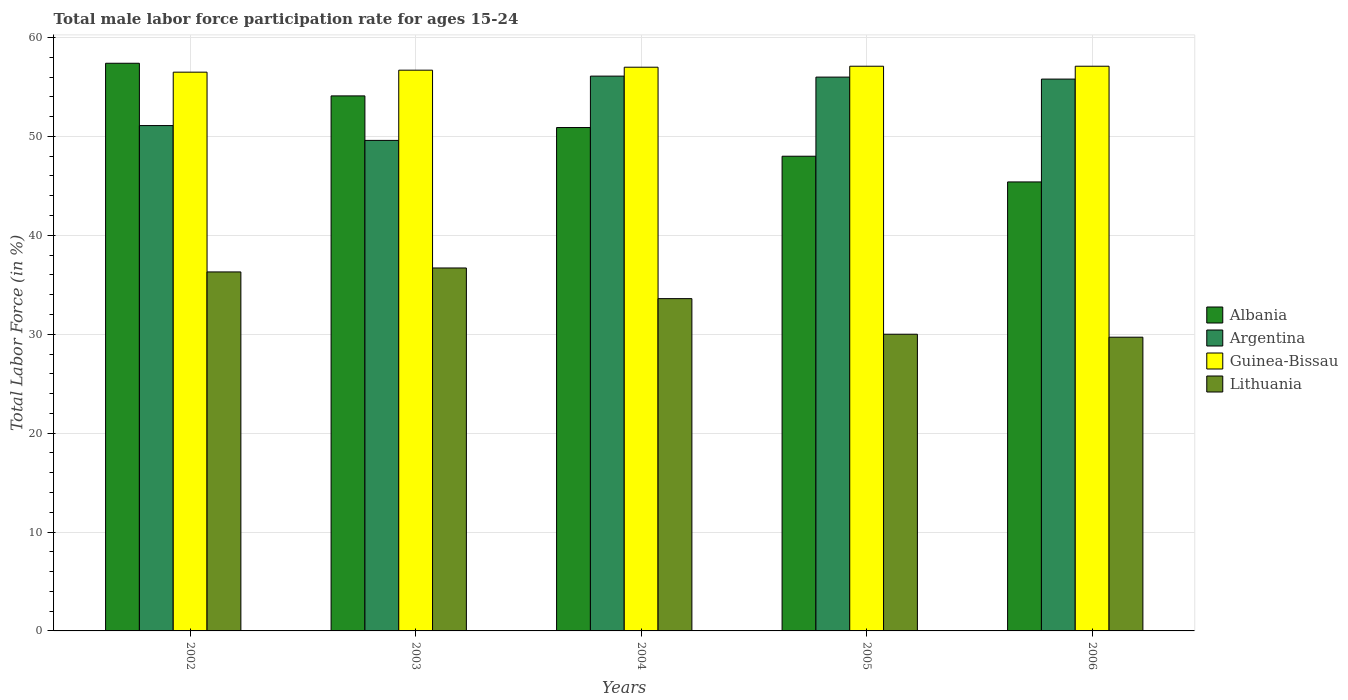How many different coloured bars are there?
Offer a terse response. 4. Are the number of bars per tick equal to the number of legend labels?
Give a very brief answer. Yes. How many bars are there on the 1st tick from the left?
Offer a terse response. 4. What is the label of the 1st group of bars from the left?
Provide a short and direct response. 2002. In how many cases, is the number of bars for a given year not equal to the number of legend labels?
Provide a short and direct response. 0. What is the male labor force participation rate in Albania in 2002?
Make the answer very short. 57.4. Across all years, what is the maximum male labor force participation rate in Albania?
Make the answer very short. 57.4. Across all years, what is the minimum male labor force participation rate in Albania?
Make the answer very short. 45.4. In which year was the male labor force participation rate in Lithuania minimum?
Keep it short and to the point. 2006. What is the total male labor force participation rate in Argentina in the graph?
Keep it short and to the point. 268.6. What is the difference between the male labor force participation rate in Lithuania in 2003 and that in 2004?
Offer a terse response. 3.1. What is the difference between the male labor force participation rate in Argentina in 2003 and the male labor force participation rate in Albania in 2004?
Provide a short and direct response. -1.3. What is the average male labor force participation rate in Guinea-Bissau per year?
Provide a short and direct response. 56.88. In the year 2006, what is the difference between the male labor force participation rate in Guinea-Bissau and male labor force participation rate in Albania?
Provide a short and direct response. 11.7. In how many years, is the male labor force participation rate in Argentina greater than 58 %?
Ensure brevity in your answer.  0. What is the ratio of the male labor force participation rate in Guinea-Bissau in 2005 to that in 2006?
Provide a succinct answer. 1. What is the difference between the highest and the second highest male labor force participation rate in Lithuania?
Keep it short and to the point. 0.4. What is the difference between the highest and the lowest male labor force participation rate in Guinea-Bissau?
Ensure brevity in your answer.  0.6. In how many years, is the male labor force participation rate in Argentina greater than the average male labor force participation rate in Argentina taken over all years?
Your answer should be very brief. 3. Is the sum of the male labor force participation rate in Lithuania in 2004 and 2006 greater than the maximum male labor force participation rate in Argentina across all years?
Your answer should be compact. Yes. What does the 4th bar from the left in 2005 represents?
Your answer should be very brief. Lithuania. What does the 1st bar from the right in 2004 represents?
Give a very brief answer. Lithuania. How many bars are there?
Your response must be concise. 20. How many years are there in the graph?
Keep it short and to the point. 5. What is the difference between two consecutive major ticks on the Y-axis?
Provide a short and direct response. 10. Are the values on the major ticks of Y-axis written in scientific E-notation?
Offer a very short reply. No. Where does the legend appear in the graph?
Provide a succinct answer. Center right. What is the title of the graph?
Provide a short and direct response. Total male labor force participation rate for ages 15-24. What is the label or title of the Y-axis?
Offer a terse response. Total Labor Force (in %). What is the Total Labor Force (in %) in Albania in 2002?
Give a very brief answer. 57.4. What is the Total Labor Force (in %) of Argentina in 2002?
Your answer should be compact. 51.1. What is the Total Labor Force (in %) in Guinea-Bissau in 2002?
Make the answer very short. 56.5. What is the Total Labor Force (in %) of Lithuania in 2002?
Provide a succinct answer. 36.3. What is the Total Labor Force (in %) of Albania in 2003?
Offer a terse response. 54.1. What is the Total Labor Force (in %) in Argentina in 2003?
Provide a short and direct response. 49.6. What is the Total Labor Force (in %) of Guinea-Bissau in 2003?
Provide a succinct answer. 56.7. What is the Total Labor Force (in %) of Lithuania in 2003?
Give a very brief answer. 36.7. What is the Total Labor Force (in %) in Albania in 2004?
Keep it short and to the point. 50.9. What is the Total Labor Force (in %) in Argentina in 2004?
Provide a succinct answer. 56.1. What is the Total Labor Force (in %) in Guinea-Bissau in 2004?
Provide a succinct answer. 57. What is the Total Labor Force (in %) in Lithuania in 2004?
Make the answer very short. 33.6. What is the Total Labor Force (in %) of Albania in 2005?
Offer a very short reply. 48. What is the Total Labor Force (in %) of Guinea-Bissau in 2005?
Provide a short and direct response. 57.1. What is the Total Labor Force (in %) of Lithuania in 2005?
Provide a succinct answer. 30. What is the Total Labor Force (in %) in Albania in 2006?
Your response must be concise. 45.4. What is the Total Labor Force (in %) of Argentina in 2006?
Ensure brevity in your answer.  55.8. What is the Total Labor Force (in %) of Guinea-Bissau in 2006?
Provide a succinct answer. 57.1. What is the Total Labor Force (in %) of Lithuania in 2006?
Your answer should be very brief. 29.7. Across all years, what is the maximum Total Labor Force (in %) of Albania?
Your answer should be very brief. 57.4. Across all years, what is the maximum Total Labor Force (in %) of Argentina?
Offer a very short reply. 56.1. Across all years, what is the maximum Total Labor Force (in %) in Guinea-Bissau?
Make the answer very short. 57.1. Across all years, what is the maximum Total Labor Force (in %) in Lithuania?
Ensure brevity in your answer.  36.7. Across all years, what is the minimum Total Labor Force (in %) in Albania?
Make the answer very short. 45.4. Across all years, what is the minimum Total Labor Force (in %) in Argentina?
Your answer should be very brief. 49.6. Across all years, what is the minimum Total Labor Force (in %) in Guinea-Bissau?
Ensure brevity in your answer.  56.5. Across all years, what is the minimum Total Labor Force (in %) in Lithuania?
Provide a succinct answer. 29.7. What is the total Total Labor Force (in %) in Albania in the graph?
Your response must be concise. 255.8. What is the total Total Labor Force (in %) in Argentina in the graph?
Provide a succinct answer. 268.6. What is the total Total Labor Force (in %) of Guinea-Bissau in the graph?
Ensure brevity in your answer.  284.4. What is the total Total Labor Force (in %) in Lithuania in the graph?
Keep it short and to the point. 166.3. What is the difference between the Total Labor Force (in %) of Albania in 2002 and that in 2003?
Your answer should be compact. 3.3. What is the difference between the Total Labor Force (in %) of Argentina in 2002 and that in 2003?
Offer a very short reply. 1.5. What is the difference between the Total Labor Force (in %) of Guinea-Bissau in 2002 and that in 2003?
Your response must be concise. -0.2. What is the difference between the Total Labor Force (in %) of Lithuania in 2002 and that in 2003?
Your answer should be compact. -0.4. What is the difference between the Total Labor Force (in %) in Argentina in 2002 and that in 2004?
Offer a very short reply. -5. What is the difference between the Total Labor Force (in %) of Guinea-Bissau in 2002 and that in 2005?
Ensure brevity in your answer.  -0.6. What is the difference between the Total Labor Force (in %) of Albania in 2003 and that in 2004?
Provide a succinct answer. 3.2. What is the difference between the Total Labor Force (in %) of Argentina in 2003 and that in 2004?
Provide a short and direct response. -6.5. What is the difference between the Total Labor Force (in %) in Argentina in 2003 and that in 2005?
Keep it short and to the point. -6.4. What is the difference between the Total Labor Force (in %) of Lithuania in 2003 and that in 2005?
Provide a short and direct response. 6.7. What is the difference between the Total Labor Force (in %) in Argentina in 2003 and that in 2006?
Your answer should be very brief. -6.2. What is the difference between the Total Labor Force (in %) in Guinea-Bissau in 2003 and that in 2006?
Offer a very short reply. -0.4. What is the difference between the Total Labor Force (in %) in Albania in 2004 and that in 2005?
Keep it short and to the point. 2.9. What is the difference between the Total Labor Force (in %) of Argentina in 2004 and that in 2005?
Provide a short and direct response. 0.1. What is the difference between the Total Labor Force (in %) of Guinea-Bissau in 2004 and that in 2005?
Your answer should be very brief. -0.1. What is the difference between the Total Labor Force (in %) in Guinea-Bissau in 2004 and that in 2006?
Your response must be concise. -0.1. What is the difference between the Total Labor Force (in %) in Lithuania in 2004 and that in 2006?
Provide a succinct answer. 3.9. What is the difference between the Total Labor Force (in %) of Argentina in 2005 and that in 2006?
Make the answer very short. 0.2. What is the difference between the Total Labor Force (in %) in Lithuania in 2005 and that in 2006?
Offer a very short reply. 0.3. What is the difference between the Total Labor Force (in %) of Albania in 2002 and the Total Labor Force (in %) of Argentina in 2003?
Ensure brevity in your answer.  7.8. What is the difference between the Total Labor Force (in %) in Albania in 2002 and the Total Labor Force (in %) in Lithuania in 2003?
Offer a very short reply. 20.7. What is the difference between the Total Labor Force (in %) of Argentina in 2002 and the Total Labor Force (in %) of Lithuania in 2003?
Provide a short and direct response. 14.4. What is the difference between the Total Labor Force (in %) of Guinea-Bissau in 2002 and the Total Labor Force (in %) of Lithuania in 2003?
Your answer should be compact. 19.8. What is the difference between the Total Labor Force (in %) in Albania in 2002 and the Total Labor Force (in %) in Argentina in 2004?
Your response must be concise. 1.3. What is the difference between the Total Labor Force (in %) in Albania in 2002 and the Total Labor Force (in %) in Lithuania in 2004?
Make the answer very short. 23.8. What is the difference between the Total Labor Force (in %) of Guinea-Bissau in 2002 and the Total Labor Force (in %) of Lithuania in 2004?
Make the answer very short. 22.9. What is the difference between the Total Labor Force (in %) of Albania in 2002 and the Total Labor Force (in %) of Lithuania in 2005?
Offer a terse response. 27.4. What is the difference between the Total Labor Force (in %) of Argentina in 2002 and the Total Labor Force (in %) of Guinea-Bissau in 2005?
Provide a succinct answer. -6. What is the difference between the Total Labor Force (in %) of Argentina in 2002 and the Total Labor Force (in %) of Lithuania in 2005?
Provide a succinct answer. 21.1. What is the difference between the Total Labor Force (in %) in Albania in 2002 and the Total Labor Force (in %) in Lithuania in 2006?
Give a very brief answer. 27.7. What is the difference between the Total Labor Force (in %) of Argentina in 2002 and the Total Labor Force (in %) of Lithuania in 2006?
Your answer should be compact. 21.4. What is the difference between the Total Labor Force (in %) of Guinea-Bissau in 2002 and the Total Labor Force (in %) of Lithuania in 2006?
Offer a very short reply. 26.8. What is the difference between the Total Labor Force (in %) in Albania in 2003 and the Total Labor Force (in %) in Argentina in 2004?
Give a very brief answer. -2. What is the difference between the Total Labor Force (in %) in Albania in 2003 and the Total Labor Force (in %) in Guinea-Bissau in 2004?
Offer a very short reply. -2.9. What is the difference between the Total Labor Force (in %) of Argentina in 2003 and the Total Labor Force (in %) of Guinea-Bissau in 2004?
Give a very brief answer. -7.4. What is the difference between the Total Labor Force (in %) of Argentina in 2003 and the Total Labor Force (in %) of Lithuania in 2004?
Provide a succinct answer. 16. What is the difference between the Total Labor Force (in %) of Guinea-Bissau in 2003 and the Total Labor Force (in %) of Lithuania in 2004?
Ensure brevity in your answer.  23.1. What is the difference between the Total Labor Force (in %) of Albania in 2003 and the Total Labor Force (in %) of Argentina in 2005?
Offer a terse response. -1.9. What is the difference between the Total Labor Force (in %) of Albania in 2003 and the Total Labor Force (in %) of Guinea-Bissau in 2005?
Your answer should be very brief. -3. What is the difference between the Total Labor Force (in %) of Albania in 2003 and the Total Labor Force (in %) of Lithuania in 2005?
Offer a terse response. 24.1. What is the difference between the Total Labor Force (in %) of Argentina in 2003 and the Total Labor Force (in %) of Guinea-Bissau in 2005?
Provide a succinct answer. -7.5. What is the difference between the Total Labor Force (in %) of Argentina in 2003 and the Total Labor Force (in %) of Lithuania in 2005?
Your answer should be very brief. 19.6. What is the difference between the Total Labor Force (in %) in Guinea-Bissau in 2003 and the Total Labor Force (in %) in Lithuania in 2005?
Ensure brevity in your answer.  26.7. What is the difference between the Total Labor Force (in %) of Albania in 2003 and the Total Labor Force (in %) of Lithuania in 2006?
Give a very brief answer. 24.4. What is the difference between the Total Labor Force (in %) of Argentina in 2003 and the Total Labor Force (in %) of Lithuania in 2006?
Your response must be concise. 19.9. What is the difference between the Total Labor Force (in %) of Guinea-Bissau in 2003 and the Total Labor Force (in %) of Lithuania in 2006?
Offer a terse response. 27. What is the difference between the Total Labor Force (in %) of Albania in 2004 and the Total Labor Force (in %) of Lithuania in 2005?
Your answer should be compact. 20.9. What is the difference between the Total Labor Force (in %) of Argentina in 2004 and the Total Labor Force (in %) of Lithuania in 2005?
Your answer should be compact. 26.1. What is the difference between the Total Labor Force (in %) of Albania in 2004 and the Total Labor Force (in %) of Guinea-Bissau in 2006?
Ensure brevity in your answer.  -6.2. What is the difference between the Total Labor Force (in %) in Albania in 2004 and the Total Labor Force (in %) in Lithuania in 2006?
Keep it short and to the point. 21.2. What is the difference between the Total Labor Force (in %) in Argentina in 2004 and the Total Labor Force (in %) in Lithuania in 2006?
Make the answer very short. 26.4. What is the difference between the Total Labor Force (in %) of Guinea-Bissau in 2004 and the Total Labor Force (in %) of Lithuania in 2006?
Your response must be concise. 27.3. What is the difference between the Total Labor Force (in %) in Albania in 2005 and the Total Labor Force (in %) in Argentina in 2006?
Provide a short and direct response. -7.8. What is the difference between the Total Labor Force (in %) of Albania in 2005 and the Total Labor Force (in %) of Guinea-Bissau in 2006?
Offer a very short reply. -9.1. What is the difference between the Total Labor Force (in %) of Albania in 2005 and the Total Labor Force (in %) of Lithuania in 2006?
Offer a very short reply. 18.3. What is the difference between the Total Labor Force (in %) in Argentina in 2005 and the Total Labor Force (in %) in Lithuania in 2006?
Offer a terse response. 26.3. What is the difference between the Total Labor Force (in %) in Guinea-Bissau in 2005 and the Total Labor Force (in %) in Lithuania in 2006?
Provide a short and direct response. 27.4. What is the average Total Labor Force (in %) of Albania per year?
Your response must be concise. 51.16. What is the average Total Labor Force (in %) in Argentina per year?
Your response must be concise. 53.72. What is the average Total Labor Force (in %) of Guinea-Bissau per year?
Your answer should be compact. 56.88. What is the average Total Labor Force (in %) of Lithuania per year?
Your answer should be very brief. 33.26. In the year 2002, what is the difference between the Total Labor Force (in %) of Albania and Total Labor Force (in %) of Lithuania?
Make the answer very short. 21.1. In the year 2002, what is the difference between the Total Labor Force (in %) of Argentina and Total Labor Force (in %) of Guinea-Bissau?
Offer a very short reply. -5.4. In the year 2002, what is the difference between the Total Labor Force (in %) in Argentina and Total Labor Force (in %) in Lithuania?
Provide a short and direct response. 14.8. In the year 2002, what is the difference between the Total Labor Force (in %) in Guinea-Bissau and Total Labor Force (in %) in Lithuania?
Your answer should be compact. 20.2. In the year 2003, what is the difference between the Total Labor Force (in %) of Albania and Total Labor Force (in %) of Lithuania?
Provide a short and direct response. 17.4. In the year 2004, what is the difference between the Total Labor Force (in %) of Albania and Total Labor Force (in %) of Argentina?
Your response must be concise. -5.2. In the year 2004, what is the difference between the Total Labor Force (in %) in Albania and Total Labor Force (in %) in Lithuania?
Make the answer very short. 17.3. In the year 2004, what is the difference between the Total Labor Force (in %) of Argentina and Total Labor Force (in %) of Lithuania?
Offer a very short reply. 22.5. In the year 2004, what is the difference between the Total Labor Force (in %) of Guinea-Bissau and Total Labor Force (in %) of Lithuania?
Your answer should be very brief. 23.4. In the year 2005, what is the difference between the Total Labor Force (in %) in Albania and Total Labor Force (in %) in Argentina?
Ensure brevity in your answer.  -8. In the year 2005, what is the difference between the Total Labor Force (in %) of Albania and Total Labor Force (in %) of Lithuania?
Give a very brief answer. 18. In the year 2005, what is the difference between the Total Labor Force (in %) of Argentina and Total Labor Force (in %) of Lithuania?
Your answer should be compact. 26. In the year 2005, what is the difference between the Total Labor Force (in %) in Guinea-Bissau and Total Labor Force (in %) in Lithuania?
Keep it short and to the point. 27.1. In the year 2006, what is the difference between the Total Labor Force (in %) of Albania and Total Labor Force (in %) of Argentina?
Provide a short and direct response. -10.4. In the year 2006, what is the difference between the Total Labor Force (in %) of Albania and Total Labor Force (in %) of Lithuania?
Keep it short and to the point. 15.7. In the year 2006, what is the difference between the Total Labor Force (in %) in Argentina and Total Labor Force (in %) in Guinea-Bissau?
Give a very brief answer. -1.3. In the year 2006, what is the difference between the Total Labor Force (in %) in Argentina and Total Labor Force (in %) in Lithuania?
Give a very brief answer. 26.1. In the year 2006, what is the difference between the Total Labor Force (in %) in Guinea-Bissau and Total Labor Force (in %) in Lithuania?
Your response must be concise. 27.4. What is the ratio of the Total Labor Force (in %) in Albania in 2002 to that in 2003?
Your response must be concise. 1.06. What is the ratio of the Total Labor Force (in %) of Argentina in 2002 to that in 2003?
Your response must be concise. 1.03. What is the ratio of the Total Labor Force (in %) in Albania in 2002 to that in 2004?
Keep it short and to the point. 1.13. What is the ratio of the Total Labor Force (in %) in Argentina in 2002 to that in 2004?
Offer a terse response. 0.91. What is the ratio of the Total Labor Force (in %) in Guinea-Bissau in 2002 to that in 2004?
Your answer should be compact. 0.99. What is the ratio of the Total Labor Force (in %) of Lithuania in 2002 to that in 2004?
Keep it short and to the point. 1.08. What is the ratio of the Total Labor Force (in %) in Albania in 2002 to that in 2005?
Your response must be concise. 1.2. What is the ratio of the Total Labor Force (in %) in Argentina in 2002 to that in 2005?
Offer a very short reply. 0.91. What is the ratio of the Total Labor Force (in %) in Guinea-Bissau in 2002 to that in 2005?
Give a very brief answer. 0.99. What is the ratio of the Total Labor Force (in %) in Lithuania in 2002 to that in 2005?
Your answer should be compact. 1.21. What is the ratio of the Total Labor Force (in %) of Albania in 2002 to that in 2006?
Provide a succinct answer. 1.26. What is the ratio of the Total Labor Force (in %) in Argentina in 2002 to that in 2006?
Your response must be concise. 0.92. What is the ratio of the Total Labor Force (in %) in Lithuania in 2002 to that in 2006?
Your answer should be very brief. 1.22. What is the ratio of the Total Labor Force (in %) of Albania in 2003 to that in 2004?
Your answer should be very brief. 1.06. What is the ratio of the Total Labor Force (in %) of Argentina in 2003 to that in 2004?
Provide a short and direct response. 0.88. What is the ratio of the Total Labor Force (in %) in Guinea-Bissau in 2003 to that in 2004?
Keep it short and to the point. 0.99. What is the ratio of the Total Labor Force (in %) in Lithuania in 2003 to that in 2004?
Offer a very short reply. 1.09. What is the ratio of the Total Labor Force (in %) in Albania in 2003 to that in 2005?
Make the answer very short. 1.13. What is the ratio of the Total Labor Force (in %) of Argentina in 2003 to that in 2005?
Give a very brief answer. 0.89. What is the ratio of the Total Labor Force (in %) of Lithuania in 2003 to that in 2005?
Give a very brief answer. 1.22. What is the ratio of the Total Labor Force (in %) of Albania in 2003 to that in 2006?
Give a very brief answer. 1.19. What is the ratio of the Total Labor Force (in %) in Argentina in 2003 to that in 2006?
Offer a terse response. 0.89. What is the ratio of the Total Labor Force (in %) of Lithuania in 2003 to that in 2006?
Offer a very short reply. 1.24. What is the ratio of the Total Labor Force (in %) of Albania in 2004 to that in 2005?
Give a very brief answer. 1.06. What is the ratio of the Total Labor Force (in %) in Guinea-Bissau in 2004 to that in 2005?
Provide a short and direct response. 1. What is the ratio of the Total Labor Force (in %) in Lithuania in 2004 to that in 2005?
Your answer should be very brief. 1.12. What is the ratio of the Total Labor Force (in %) in Albania in 2004 to that in 2006?
Ensure brevity in your answer.  1.12. What is the ratio of the Total Labor Force (in %) of Argentina in 2004 to that in 2006?
Your answer should be compact. 1.01. What is the ratio of the Total Labor Force (in %) in Lithuania in 2004 to that in 2006?
Ensure brevity in your answer.  1.13. What is the ratio of the Total Labor Force (in %) of Albania in 2005 to that in 2006?
Ensure brevity in your answer.  1.06. What is the difference between the highest and the second highest Total Labor Force (in %) of Lithuania?
Your answer should be very brief. 0.4. What is the difference between the highest and the lowest Total Labor Force (in %) of Lithuania?
Your response must be concise. 7. 